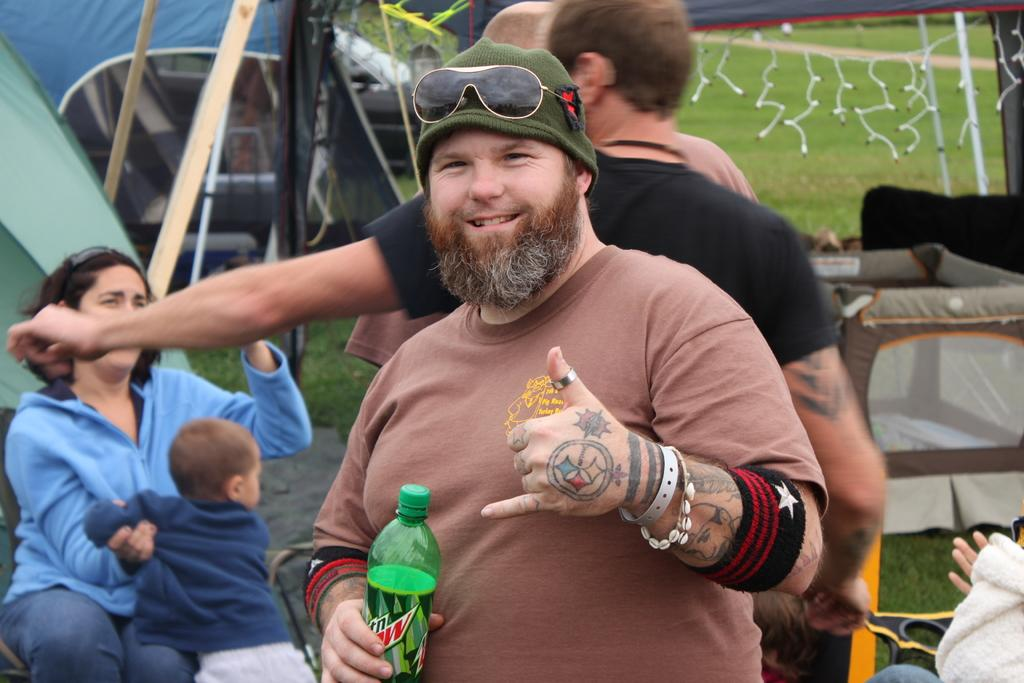What are the people in the middle of the image doing? The people in the middle of the image are standing and holding something. Can you describe the woman on the bottom left side of the image? The woman on the bottom left side of the image is sitting and holding a baby. What is visible behind the woman? There are tents behind the woman. What type of shop can be seen in the background of the image? There is no shop visible in the image. How many accounts does the woman have with the baby? The woman is not interacting with any accounts in the image; she is holding a baby. 